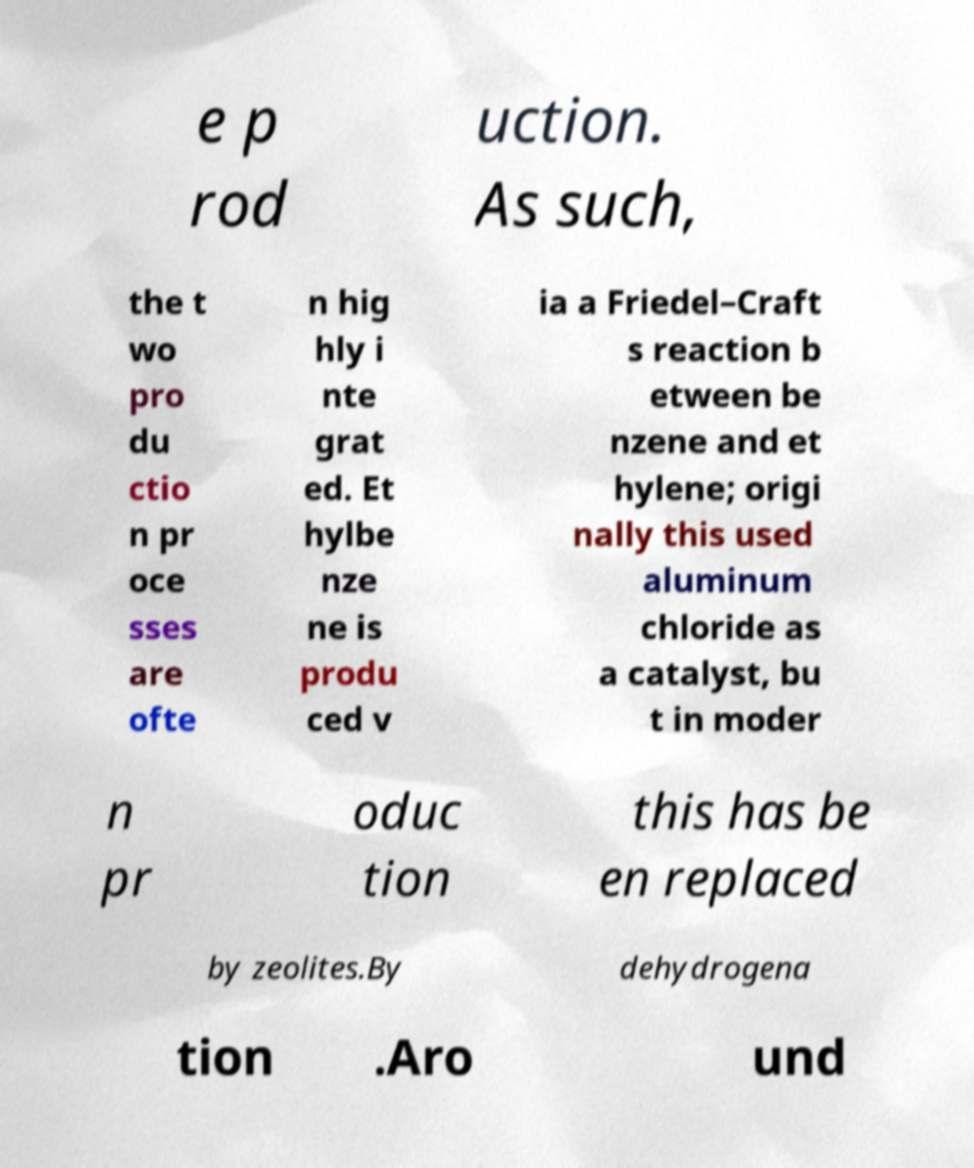There's text embedded in this image that I need extracted. Can you transcribe it verbatim? e p rod uction. As such, the t wo pro du ctio n pr oce sses are ofte n hig hly i nte grat ed. Et hylbe nze ne is produ ced v ia a Friedel–Craft s reaction b etween be nzene and et hylene; origi nally this used aluminum chloride as a catalyst, bu t in moder n pr oduc tion this has be en replaced by zeolites.By dehydrogena tion .Aro und 